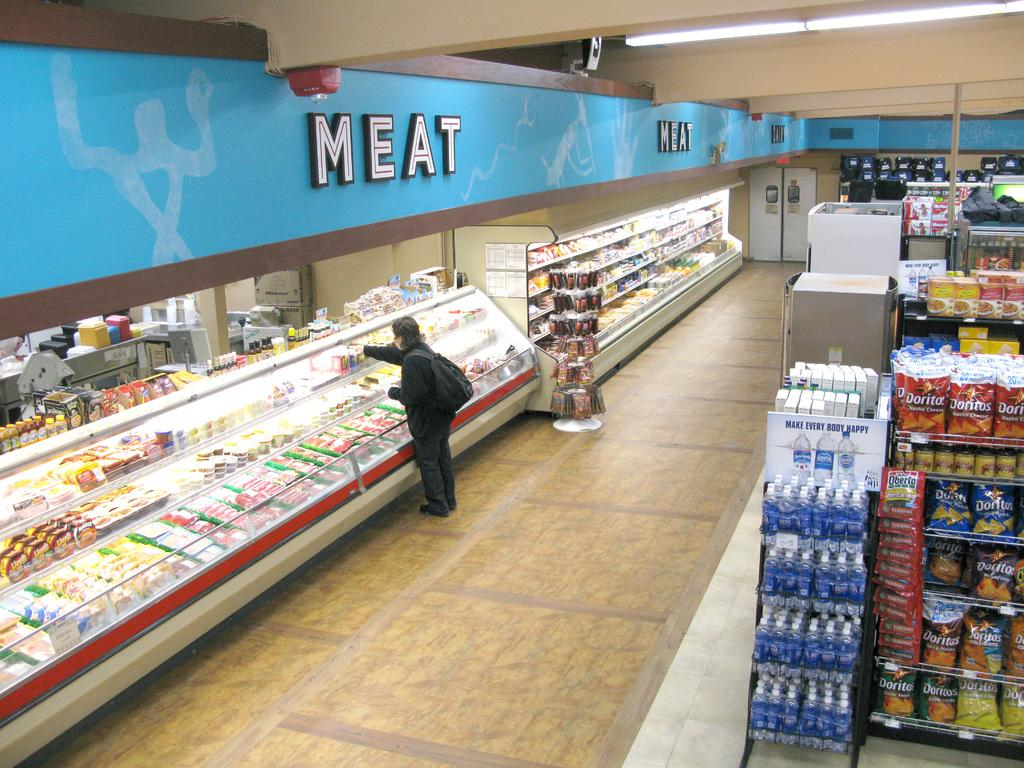<image>
Provide a brief description of the given image. A person in the meat section of a grocery store 